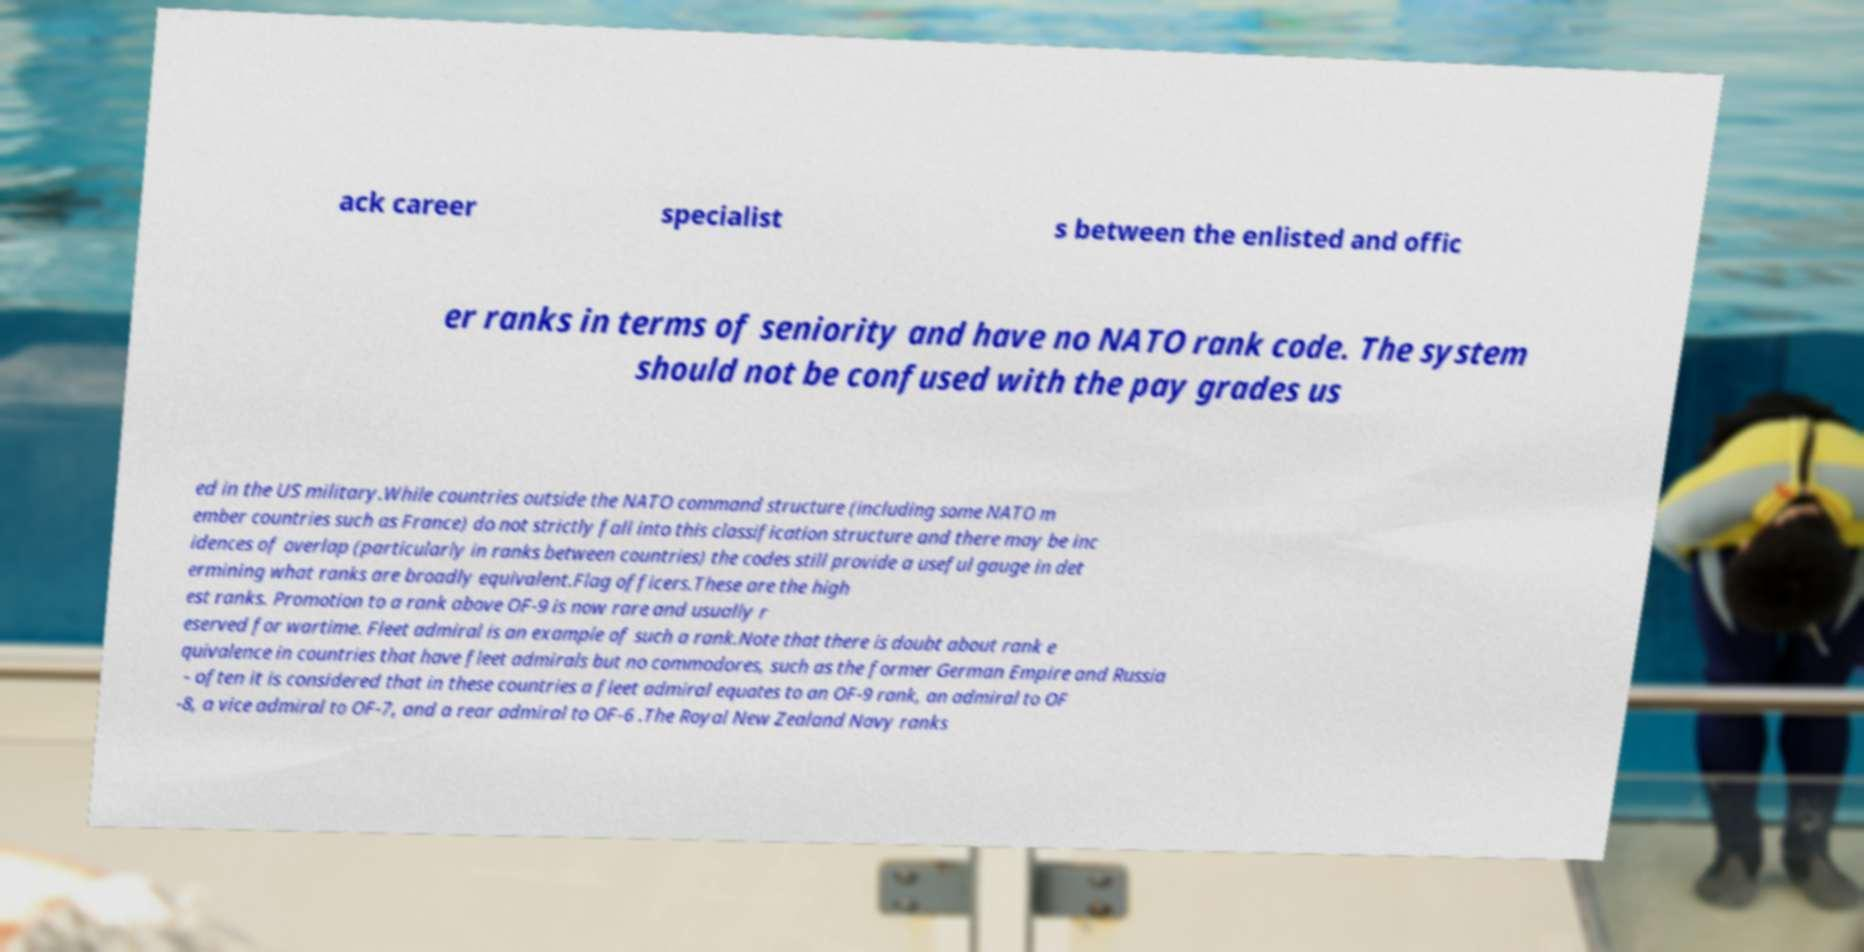For documentation purposes, I need the text within this image transcribed. Could you provide that? ack career specialist s between the enlisted and offic er ranks in terms of seniority and have no NATO rank code. The system should not be confused with the pay grades us ed in the US military.While countries outside the NATO command structure (including some NATO m ember countries such as France) do not strictly fall into this classification structure and there may be inc idences of overlap (particularly in ranks between countries) the codes still provide a useful gauge in det ermining what ranks are broadly equivalent.Flag officers.These are the high est ranks. Promotion to a rank above OF-9 is now rare and usually r eserved for wartime. Fleet admiral is an example of such a rank.Note that there is doubt about rank e quivalence in countries that have fleet admirals but no commodores, such as the former German Empire and Russia - often it is considered that in these countries a fleet admiral equates to an OF-9 rank, an admiral to OF -8, a vice admiral to OF-7, and a rear admiral to OF-6 .The Royal New Zealand Navy ranks 